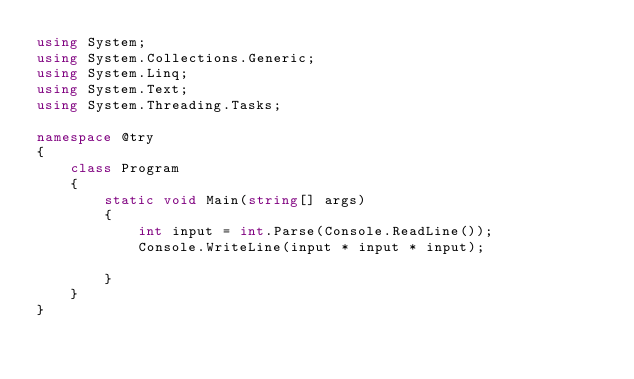<code> <loc_0><loc_0><loc_500><loc_500><_C#_>using System;
using System.Collections.Generic;
using System.Linq;
using System.Text;
using System.Threading.Tasks;

namespace @try
{
    class Program
    {
        static void Main(string[] args)
        {
            int input = int.Parse(Console.ReadLine());
            Console.WriteLine(input * input * input);
        
        }
    }
}</code> 